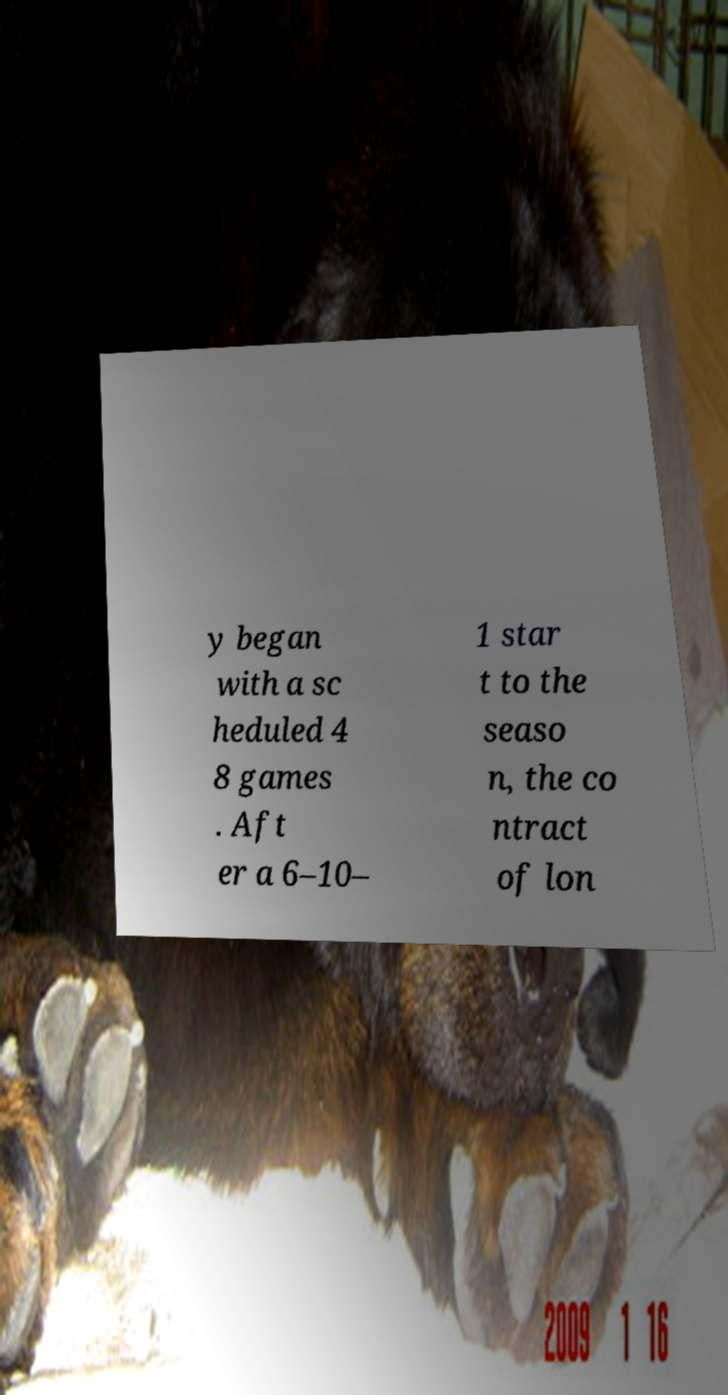Could you extract and type out the text from this image? y began with a sc heduled 4 8 games . Aft er a 6–10– 1 star t to the seaso n, the co ntract of lon 